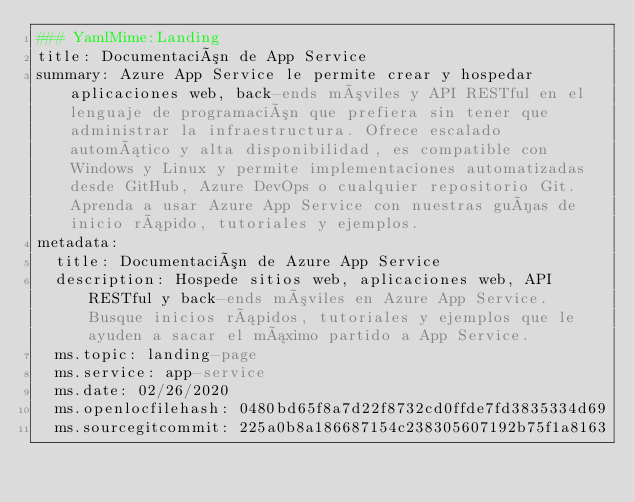Convert code to text. <code><loc_0><loc_0><loc_500><loc_500><_YAML_>### YamlMime:Landing
title: Documentación de App Service
summary: Azure App Service le permite crear y hospedar aplicaciones web, back-ends móviles y API RESTful en el lenguaje de programación que prefiera sin tener que administrar la infraestructura. Ofrece escalado automático y alta disponibilidad, es compatible con Windows y Linux y permite implementaciones automatizadas desde GitHub, Azure DevOps o cualquier repositorio Git. Aprenda a usar Azure App Service con nuestras guías de inicio rápido, tutoriales y ejemplos.
metadata:
  title: Documentación de Azure App Service
  description: Hospede sitios web, aplicaciones web, API RESTful y back-ends móviles en Azure App Service. Busque inicios rápidos, tutoriales y ejemplos que le ayuden a sacar el máximo partido a App Service.
  ms.topic: landing-page
  ms.service: app-service
  ms.date: 02/26/2020
  ms.openlocfilehash: 0480bd65f8a7d22f8732cd0ffde7fd3835334d69
  ms.sourcegitcommit: 225a0b8a186687154c238305607192b75f1a8163</code> 